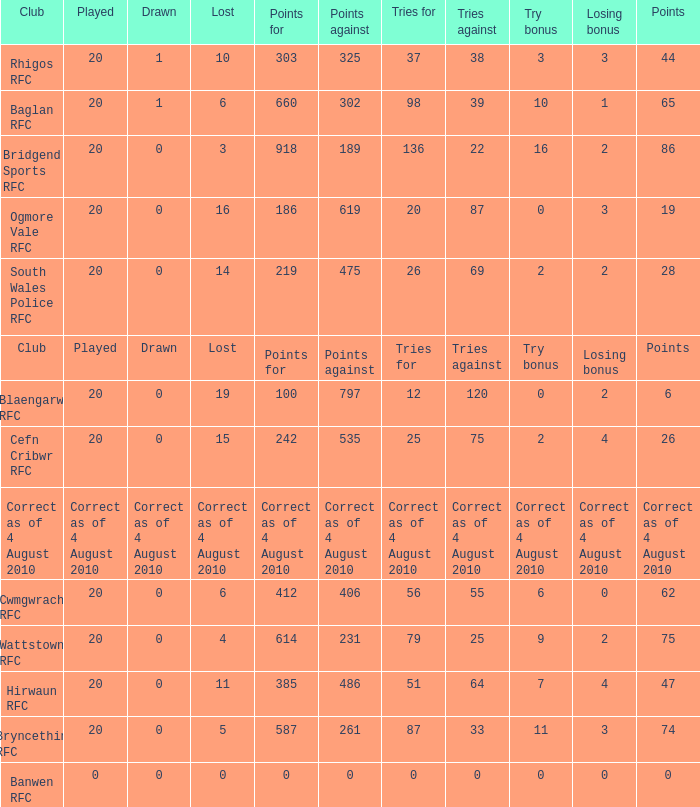What is the points against when the losing bonus is 0 and the club is banwen rfc? 0.0. 